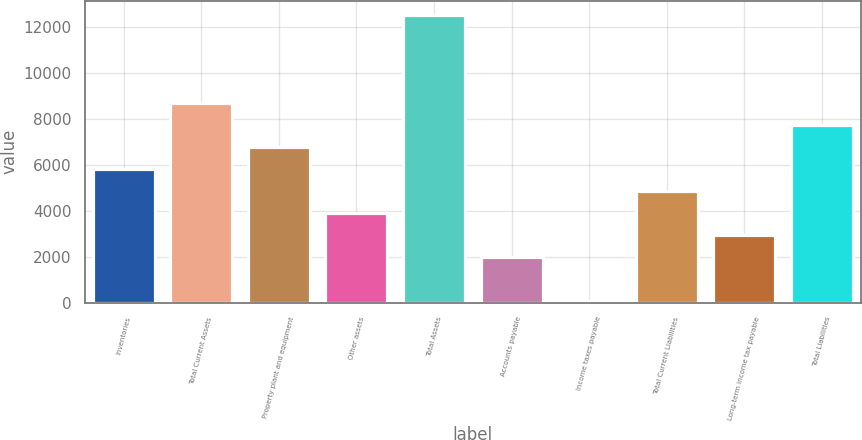<chart> <loc_0><loc_0><loc_500><loc_500><bar_chart><fcel>Inventories<fcel>Total Current Assets<fcel>Property plant and equipment<fcel>Other assets<fcel>Total Assets<fcel>Accounts payable<fcel>Income taxes payable<fcel>Total Current Liabilities<fcel>Long-term income tax payable<fcel>Total Liabilities<nl><fcel>5809.78<fcel>8678.47<fcel>6766.01<fcel>3897.32<fcel>12503.4<fcel>1984.86<fcel>72.4<fcel>4853.55<fcel>2941.09<fcel>7722.24<nl></chart> 